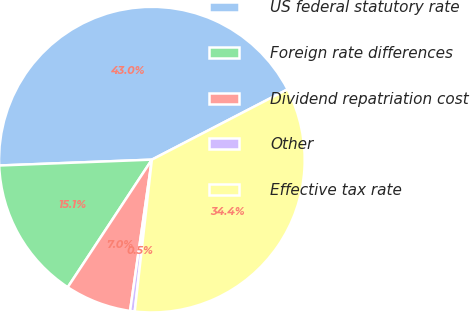Convert chart. <chart><loc_0><loc_0><loc_500><loc_500><pie_chart><fcel>US federal statutory rate<fcel>Foreign rate differences<fcel>Dividend repatriation cost<fcel>Other<fcel>Effective tax rate<nl><fcel>43.0%<fcel>15.11%<fcel>7.0%<fcel>0.49%<fcel>34.4%<nl></chart> 